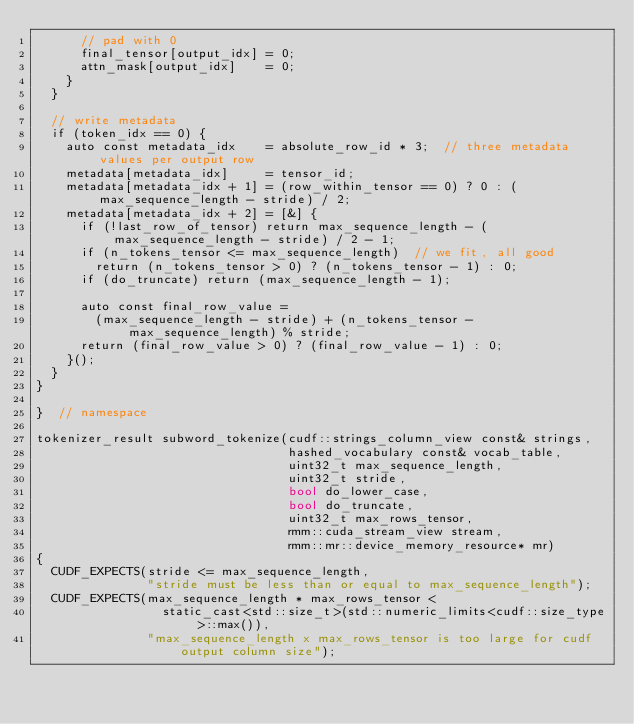<code> <loc_0><loc_0><loc_500><loc_500><_Cuda_>      // pad with 0
      final_tensor[output_idx] = 0;
      attn_mask[output_idx]    = 0;
    }
  }

  // write metadata
  if (token_idx == 0) {
    auto const metadata_idx    = absolute_row_id * 3;  // three metadata values per output row
    metadata[metadata_idx]     = tensor_id;
    metadata[metadata_idx + 1] = (row_within_tensor == 0) ? 0 : (max_sequence_length - stride) / 2;
    metadata[metadata_idx + 2] = [&] {
      if (!last_row_of_tensor) return max_sequence_length - (max_sequence_length - stride) / 2 - 1;
      if (n_tokens_tensor <= max_sequence_length)  // we fit, all good
        return (n_tokens_tensor > 0) ? (n_tokens_tensor - 1) : 0;
      if (do_truncate) return (max_sequence_length - 1);

      auto const final_row_value =
        (max_sequence_length - stride) + (n_tokens_tensor - max_sequence_length) % stride;
      return (final_row_value > 0) ? (final_row_value - 1) : 0;
    }();
  }
}

}  // namespace

tokenizer_result subword_tokenize(cudf::strings_column_view const& strings,
                                  hashed_vocabulary const& vocab_table,
                                  uint32_t max_sequence_length,
                                  uint32_t stride,
                                  bool do_lower_case,
                                  bool do_truncate,
                                  uint32_t max_rows_tensor,
                                  rmm::cuda_stream_view stream,
                                  rmm::mr::device_memory_resource* mr)
{
  CUDF_EXPECTS(stride <= max_sequence_length,
               "stride must be less than or equal to max_sequence_length");
  CUDF_EXPECTS(max_sequence_length * max_rows_tensor <
                 static_cast<std::size_t>(std::numeric_limits<cudf::size_type>::max()),
               "max_sequence_length x max_rows_tensor is too large for cudf output column size");</code> 